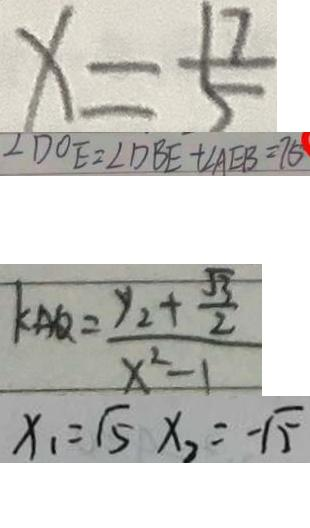<formula> <loc_0><loc_0><loc_500><loc_500>x = \frac { 1 7 } { 5 } 
 \angle D O E = \angle D B E + \angle A E B = 7 5 
 k _ { A Q } = \frac { y _ { 2 } + \frac { \sqrt { 3 } } { 2 } } { x ^ { 2 } - 1 } 
 x _ { 1 } = \sqrt { 5 } x _ { 2 } = - \sqrt { 5 }</formula> 